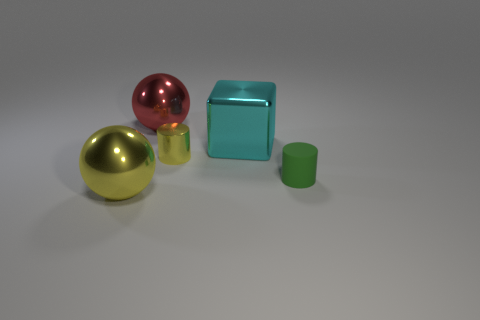Are the yellow cylinder and the green thing made of the same material?
Ensure brevity in your answer.  No. Is the number of green things less than the number of big gray metallic objects?
Your answer should be very brief. No. Is the large cyan thing the same shape as the tiny metallic object?
Provide a succinct answer. No. What color is the large block?
Make the answer very short. Cyan. What number of other objects are the same material as the yellow cylinder?
Your answer should be compact. 3. How many gray things are either big cubes or metallic cylinders?
Your response must be concise. 0. There is a yellow metallic object that is to the right of the large yellow shiny object; is its shape the same as the metal thing in front of the tiny green rubber cylinder?
Offer a very short reply. No. There is a metal cylinder; is its color the same as the sphere that is to the right of the big yellow metal ball?
Provide a short and direct response. No. Does the small object on the left side of the rubber cylinder have the same color as the small matte thing?
Your answer should be compact. No. How many objects are either small metal cylinders or yellow metallic objects behind the large yellow metallic object?
Keep it short and to the point. 1. 